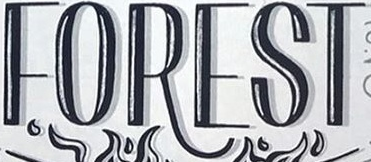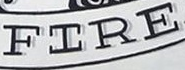What words are shown in these images in order, separated by a semicolon? FOREST; FIRE 